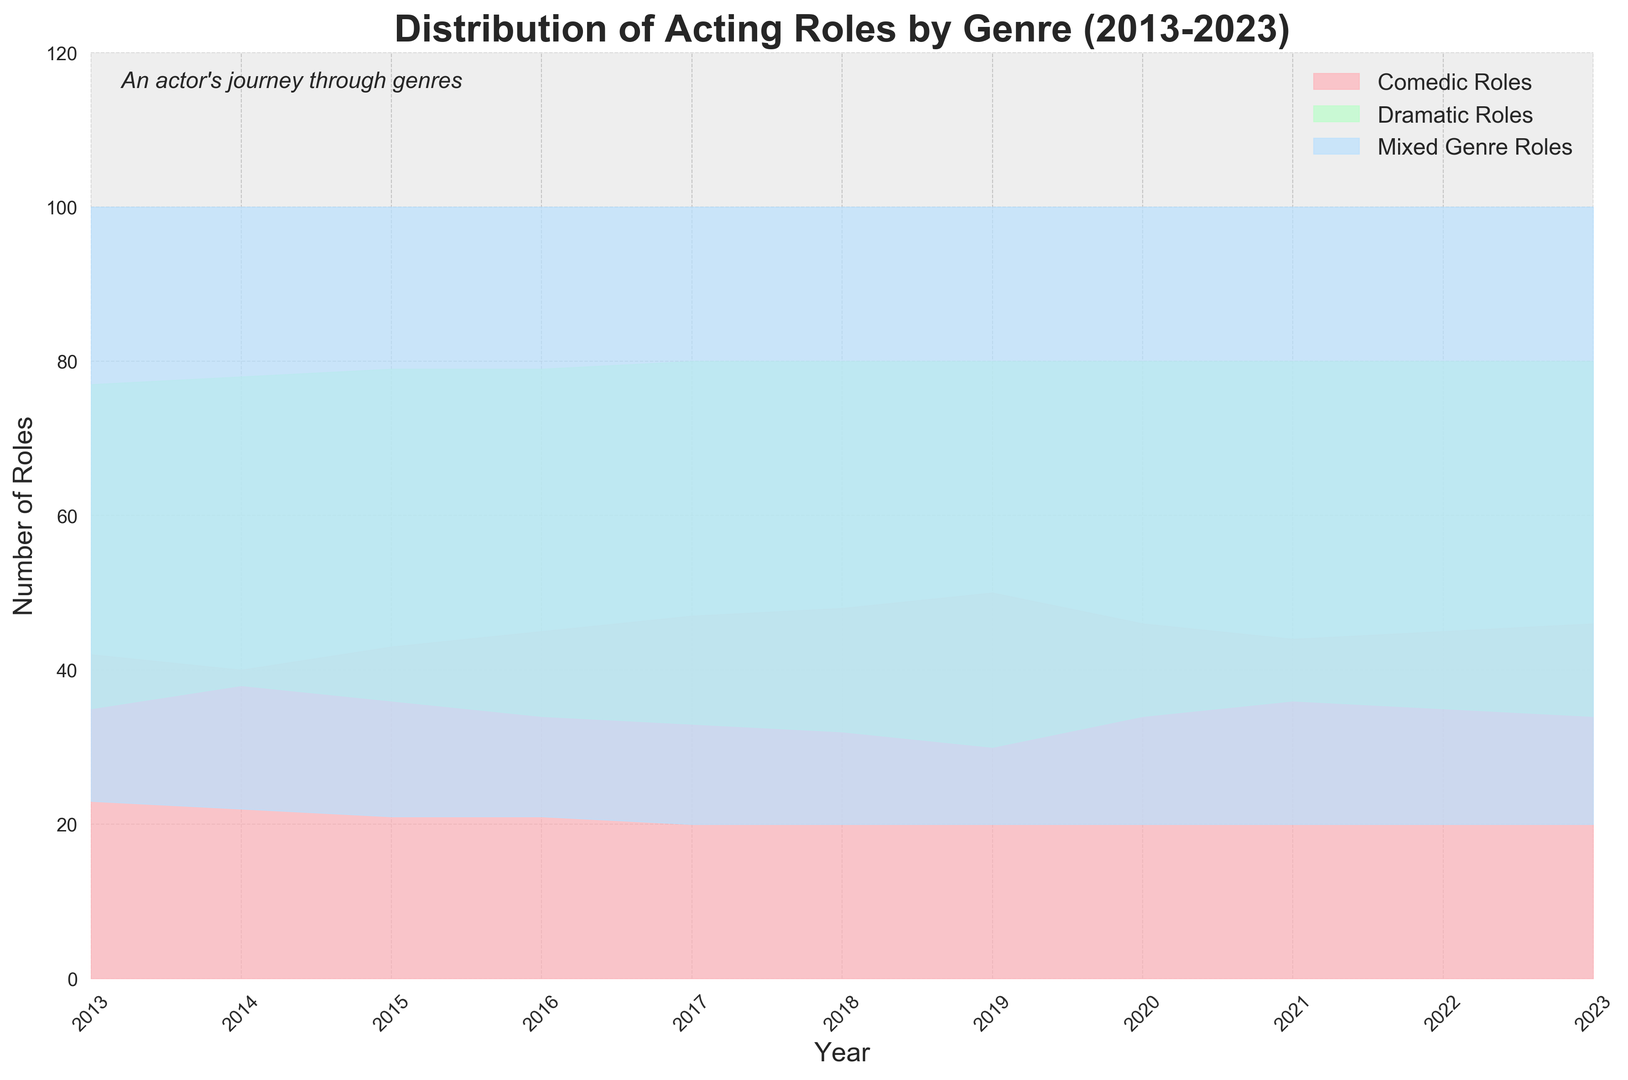What year had the highest number of comedic roles? Look at the red area on the chart and identify the peak of the Comedic Roles over time. The peak occurs in 2019, where the number of comedic roles reaches its highest point.
Answer: 2019 In which year did dramatic roles equal comedic roles? Observe where the green area for Dramatic Roles and the red area for Comedic Roles have the same heights. This overlap occurs in 2014 when both are nearly equal at around 38-40 roles each.
Answer: 2014 How did the number of mixed genre roles change over the decade? Follow the blue area representing Mixed Genre Roles throughout the years. The number of mixed genre roles remains relatively constant at around 20-23 roles, showing minimal fluctuation over the 10 years.
Answer: Relatively constant What is the total number of acting roles (sum of all genres) in 2020? Sum the values of Comedic Roles, Dramatic Roles, and Mixed Genre Roles for the year 2020. The values are 46 (Comedic) + 34 (Dramatic) + 20 (Mixed) = 100.
Answer: 100 Which genre saw the most consistent trend over the years? Examine the three areas: red for Comedic Roles, green for Dramatic Roles, and blue for Mixed Genre Roles. The Mixed Genre Roles have the most consistent trend with the least change annually, staying around 20-23 roles.
Answer: Mixed Genre Roles In what year was the sum of comedic and dramatic roles the highest? Sum up the Comedic and Dramatic Roles for each year and compare. The highest sum occurs in 2019 with Comedic (50) + Dramatic (30) = 80 roles.
Answer: 2019 How did the average number of dramatic roles per year compare to comedic roles from 2013 to 2023? Calculate the average of Dramatic Roles and Comedic Roles separately over the 11-year period. Dramatic Roles average (35.09) is lower compared to Comedic Roles average (45.18).
Answer: Lower What is the difference in the number of comedic roles between 2013 and 2023? Subtract the number of Comedic Roles in 2013 from those in 2023. Difference: 46 (2023) - 42 (2013) = 4 roles.
Answer: 4 In which year did mixed genre roles have the least percentage of the total roles? Calculate the percentage of Mixed Genre Roles out of the total roles for each year and identify the smallest percentage. In 2017, Mixed Genre Roles were 20 out of a total (47+33+20) = 20/100 = 20%.
Answer: 2017 How do comedic roles in 2020 compare to the average number of comedic roles from 2013 to 2023? First, determine the average number of Comedic Roles (sum of all years' Comedic Roles divided by 11). The average is (42 + 40 + 43 + 45 + 47 + 48 + 50 + 46 + 44 + 45 + 46) / 11 ≈ 45.18. Then, compare this to the 2020 Comedic Roles (46). In 2020, they are slightly above the average.
Answer: Above average 